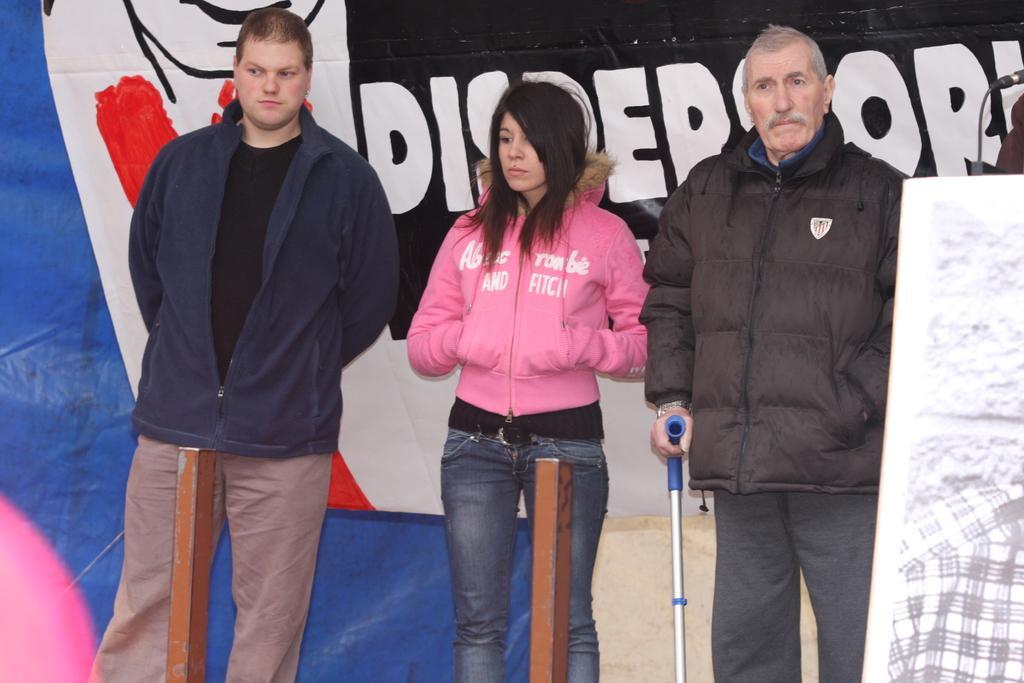Describe this image in one or two sentences. In this image there are two men and a woman standing. The man to the right is holding a stick in his hand. Behind them there is a plastic sheet. There is text on the plastic sheet. In the top right there is a microphone. To the right there is a board. 